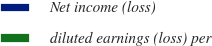Convert chart. <chart><loc_0><loc_0><loc_500><loc_500><pie_chart><fcel>Net income (loss)<fcel>diluted earnings (loss) per<nl><fcel>100.0%<fcel>0.0%<nl></chart> 